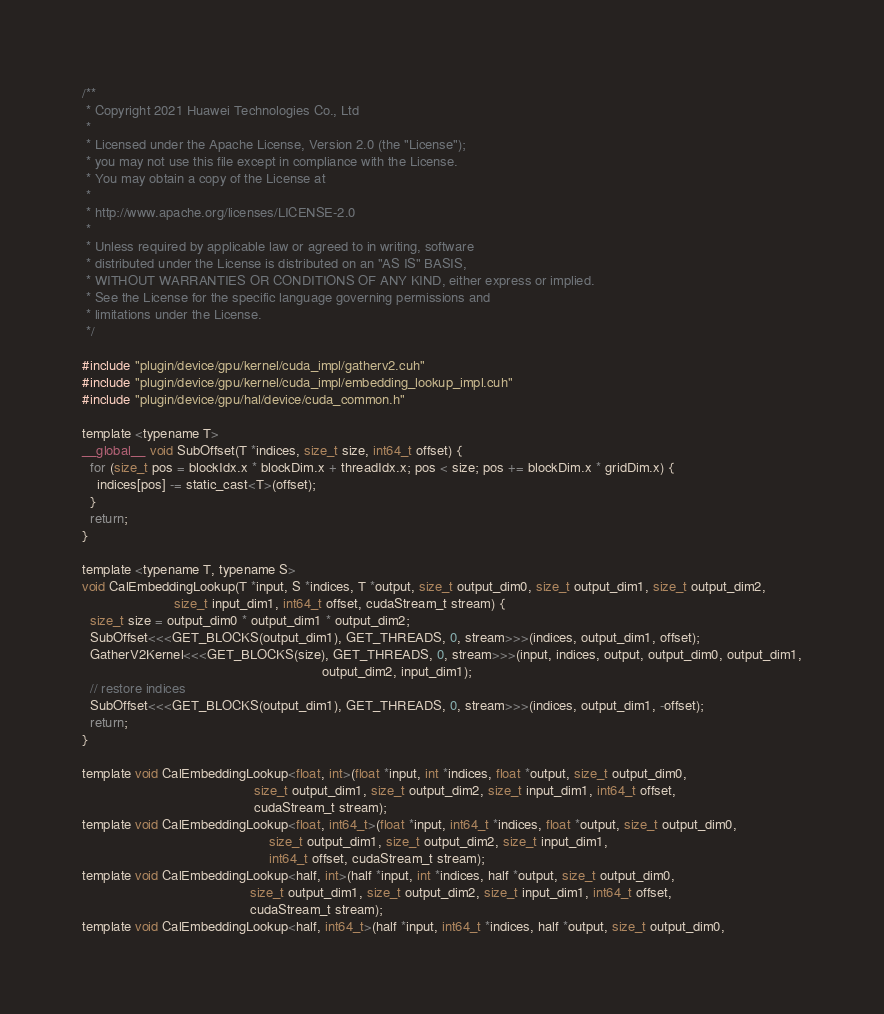<code> <loc_0><loc_0><loc_500><loc_500><_Cuda_>/**
 * Copyright 2021 Huawei Technologies Co., Ltd
 *
 * Licensed under the Apache License, Version 2.0 (the "License");
 * you may not use this file except in compliance with the License.
 * You may obtain a copy of the License at
 *
 * http://www.apache.org/licenses/LICENSE-2.0
 *
 * Unless required by applicable law or agreed to in writing, software
 * distributed under the License is distributed on an "AS IS" BASIS,
 * WITHOUT WARRANTIES OR CONDITIONS OF ANY KIND, either express or implied.
 * See the License for the specific language governing permissions and
 * limitations under the License.
 */

#include "plugin/device/gpu/kernel/cuda_impl/gatherv2.cuh"
#include "plugin/device/gpu/kernel/cuda_impl/embedding_lookup_impl.cuh"
#include "plugin/device/gpu/hal/device/cuda_common.h"

template <typename T>
__global__ void SubOffset(T *indices, size_t size, int64_t offset) {
  for (size_t pos = blockIdx.x * blockDim.x + threadIdx.x; pos < size; pos += blockDim.x * gridDim.x) {
    indices[pos] -= static_cast<T>(offset);
  }
  return;
}

template <typename T, typename S>
void CalEmbeddingLookup(T *input, S *indices, T *output, size_t output_dim0, size_t output_dim1, size_t output_dim2,
                        size_t input_dim1, int64_t offset, cudaStream_t stream) {
  size_t size = output_dim0 * output_dim1 * output_dim2;
  SubOffset<<<GET_BLOCKS(output_dim1), GET_THREADS, 0, stream>>>(indices, output_dim1, offset);
  GatherV2Kernel<<<GET_BLOCKS(size), GET_THREADS, 0, stream>>>(input, indices, output, output_dim0, output_dim1,
                                                               output_dim2, input_dim1);
  // restore indices
  SubOffset<<<GET_BLOCKS(output_dim1), GET_THREADS, 0, stream>>>(indices, output_dim1, -offset);
  return;
}

template void CalEmbeddingLookup<float, int>(float *input, int *indices, float *output, size_t output_dim0,
                                             size_t output_dim1, size_t output_dim2, size_t input_dim1, int64_t offset,
                                             cudaStream_t stream);
template void CalEmbeddingLookup<float, int64_t>(float *input, int64_t *indices, float *output, size_t output_dim0,
                                                 size_t output_dim1, size_t output_dim2, size_t input_dim1,
                                                 int64_t offset, cudaStream_t stream);
template void CalEmbeddingLookup<half, int>(half *input, int *indices, half *output, size_t output_dim0,
                                            size_t output_dim1, size_t output_dim2, size_t input_dim1, int64_t offset,
                                            cudaStream_t stream);
template void CalEmbeddingLookup<half, int64_t>(half *input, int64_t *indices, half *output, size_t output_dim0,</code> 